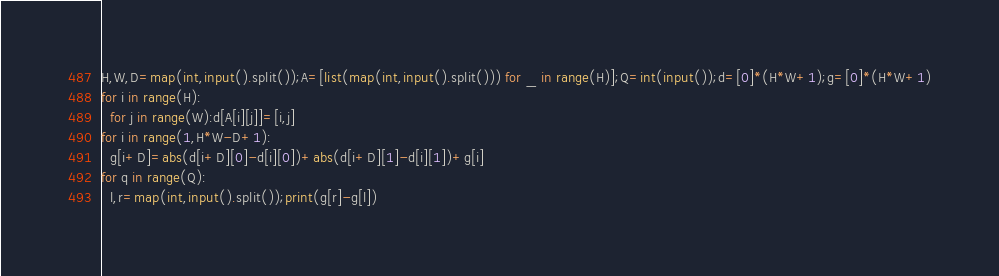<code> <loc_0><loc_0><loc_500><loc_500><_Python_>H,W,D=map(int,input().split());A=[list(map(int,input().split())) for _ in range(H)];Q=int(input());d=[0]*(H*W+1);g=[0]*(H*W+1)
for i in range(H):
  for j in range(W):d[A[i][j]]=[i,j]
for i in range(1,H*W-D+1):
  g[i+D]=abs(d[i+D][0]-d[i][0])+abs(d[i+D][1]-d[i][1])+g[i]
for q in range(Q):
  l,r=map(int,input().split());print(g[r]-g[l])</code> 